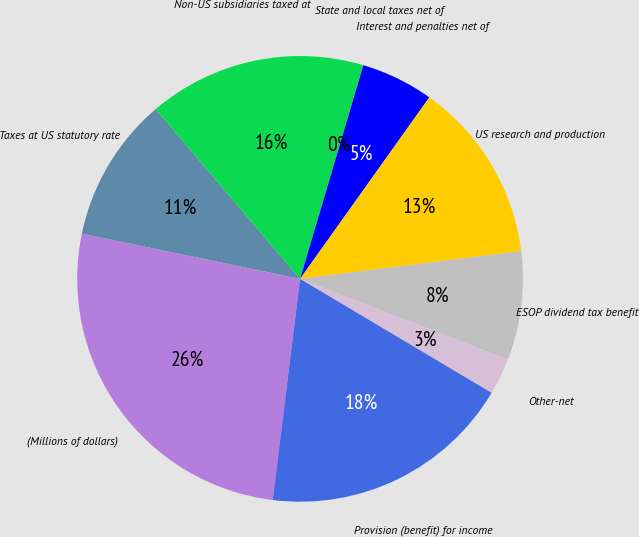Convert chart to OTSL. <chart><loc_0><loc_0><loc_500><loc_500><pie_chart><fcel>(Millions of dollars)<fcel>Taxes at US statutory rate<fcel>Non-US subsidiaries taxed at<fcel>State and local taxes net of<fcel>Interest and penalties net of<fcel>US research and production<fcel>ESOP dividend tax benefit<fcel>Other-net<fcel>Provision (benefit) for income<nl><fcel>26.3%<fcel>10.53%<fcel>15.79%<fcel>0.01%<fcel>5.27%<fcel>13.16%<fcel>7.9%<fcel>2.64%<fcel>18.42%<nl></chart> 